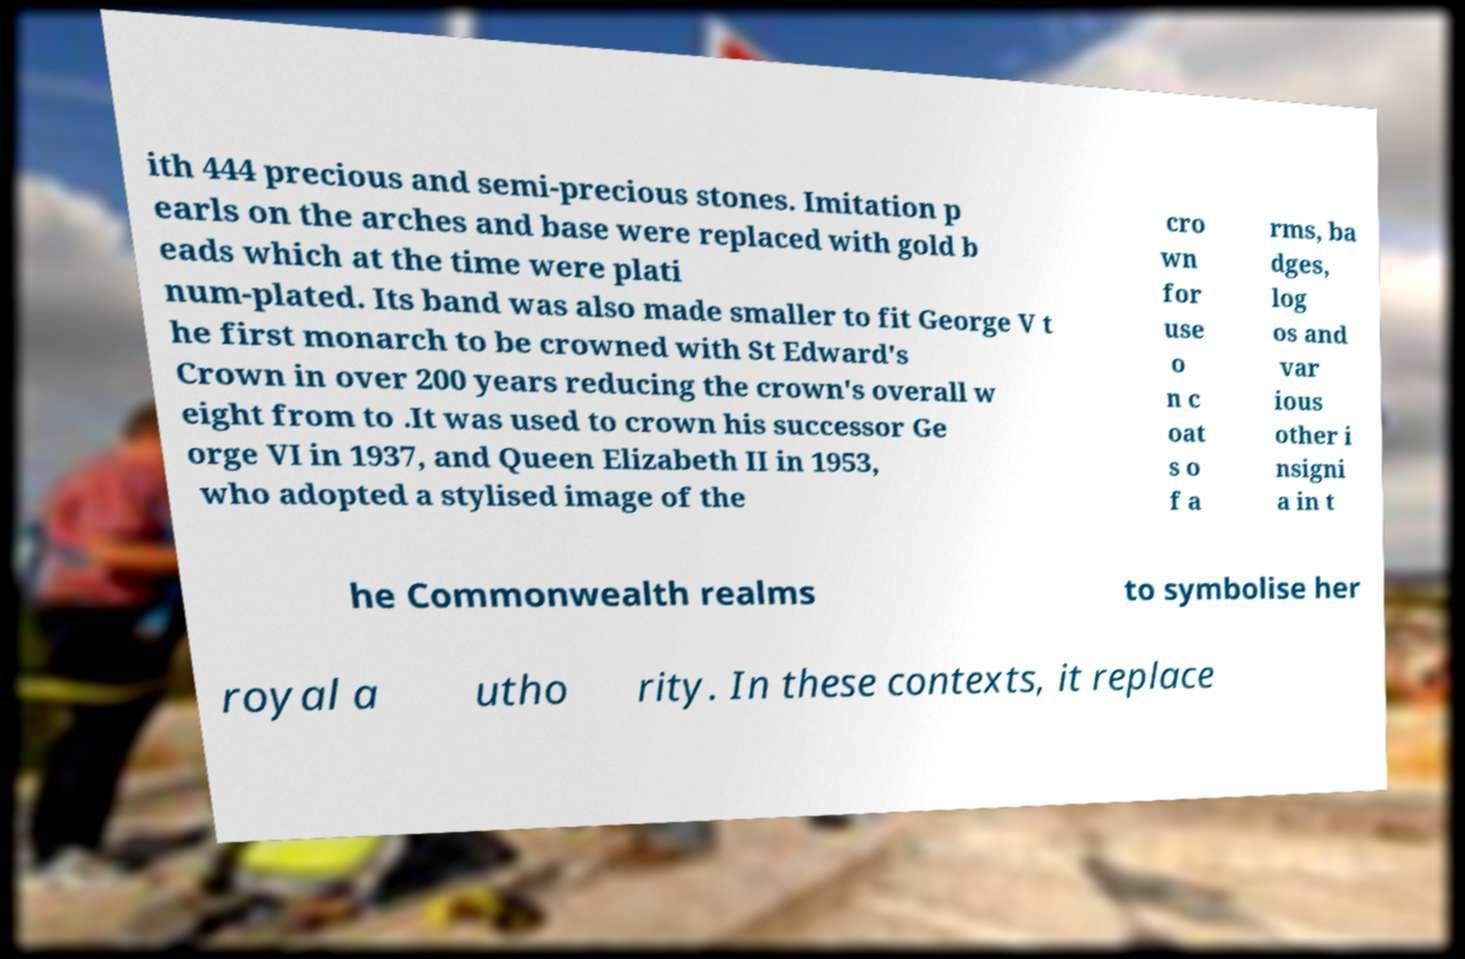What messages or text are displayed in this image? I need them in a readable, typed format. ith 444 precious and semi-precious stones. Imitation p earls on the arches and base were replaced with gold b eads which at the time were plati num-plated. Its band was also made smaller to fit George V t he first monarch to be crowned with St Edward's Crown in over 200 years reducing the crown's overall w eight from to .It was used to crown his successor Ge orge VI in 1937, and Queen Elizabeth II in 1953, who adopted a stylised image of the cro wn for use o n c oat s o f a rms, ba dges, log os and var ious other i nsigni a in t he Commonwealth realms to symbolise her royal a utho rity. In these contexts, it replace 